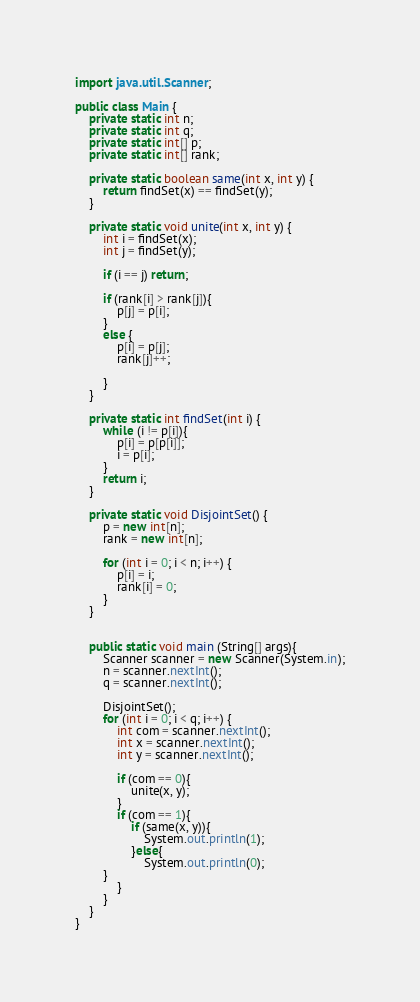<code> <loc_0><loc_0><loc_500><loc_500><_Java_>import java.util.Scanner;
 
public class Main {
    private static int n;
    private static int q;
    private static int[] p;
    private static int[] rank;
 
    private static boolean same(int x, int y) {
        return findSet(x) == findSet(y);
    }
 
    private static void unite(int x, int y) {
        int i = findSet(x);
        int j = findSet(y);
 
        if (i == j) return;

        if (rank[i] > rank[j]){
            p[j] = p[i];
        }
        else {
            p[i] = p[j];
            rank[j]++;

        }	
    }
 
    private static int findSet(int i) {
        while (i != p[i]){
            p[i] = p[p[i]];
            i = p[i];
        }
        return i;
    }
 
    private static void DisjointSet() {
        p = new int[n];
        rank = new int[n];
 
        for (int i = 0; i < n; i++) {
            p[i] = i;
            rank[i] = 0;
        }
    }
 
 
    public static void main (String[] args){
        Scanner scanner = new Scanner(System.in);
        n = scanner.nextInt();
        q = scanner.nextInt();
 
        DisjointSet();
        for (int i = 0; i < q; i++) {
            int com = scanner.nextInt();
            int x = scanner.nextInt();
            int y = scanner.nextInt();
 
            if (com == 0){
                unite(x, y);
            }
            if (com == 1){
                if (same(x, y)){
                    System.out.println(1);
                }else{
                    System.out.println(0);
		}
            }
        }
    }
}</code> 